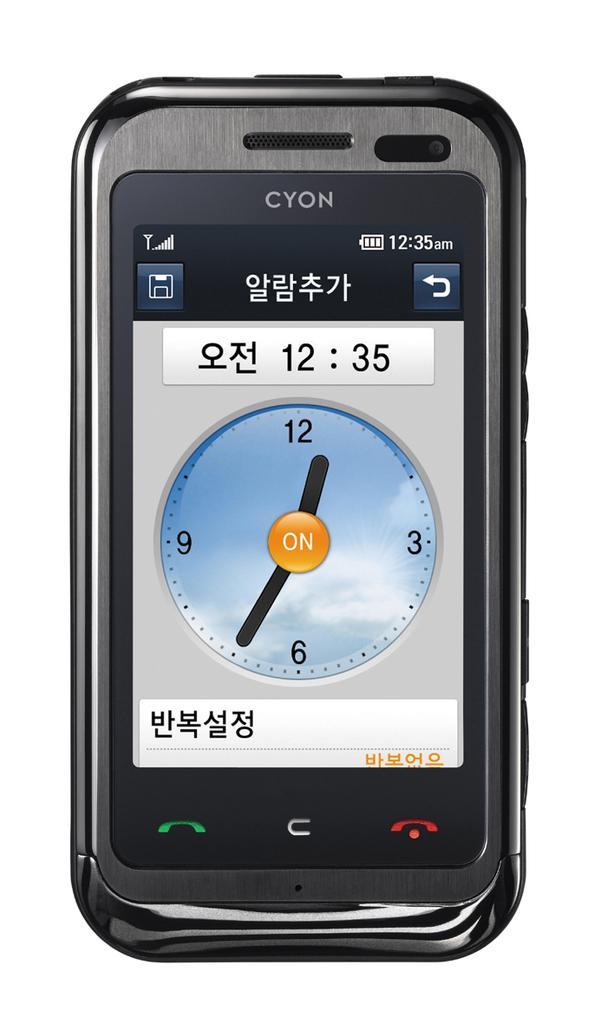<image>
Render a clear and concise summary of the photo. The clock on the cell phone is showing 12:35. 